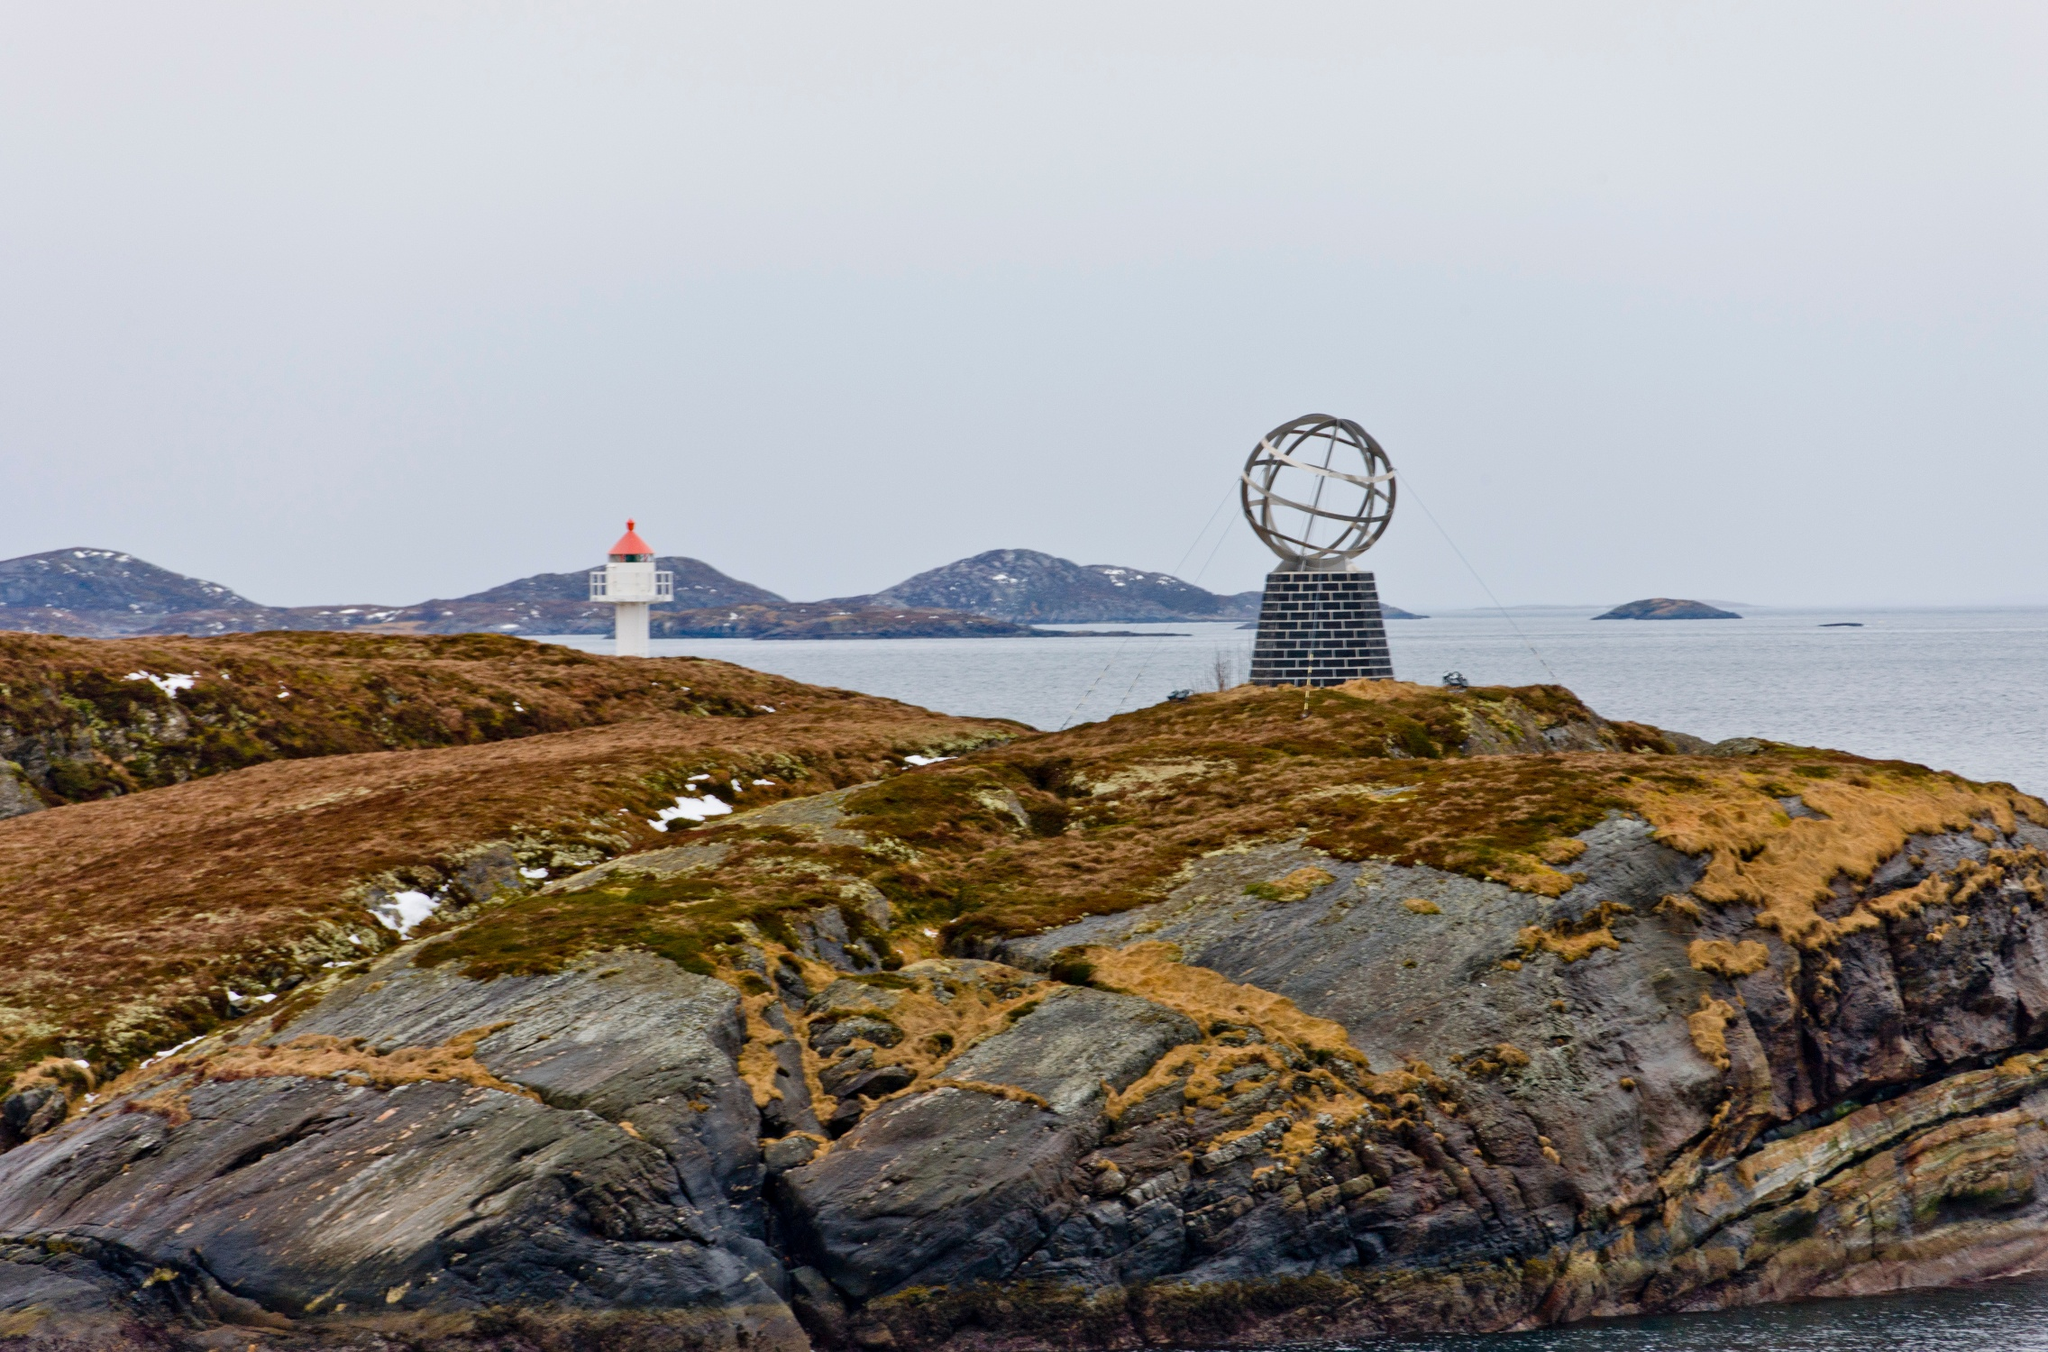What is this photo about? This photo captures the iconic North Cape in Northern Norway, known for its breathtaking seascapes and unique geographical landmarks. Center stage in the image is the large metal globe sculpture perched on a rugged stone pedestal, symbolizing its status as one of the northernmost accessible points in Europe. This sculpture, gleaming against the overcast sky, serves as an enticing focal point for visitors from around the world. The composition skillfully balances this man-made marvel with the expansive natural beauty of the North, including a quaint white and red lighthouse seen in the distance, stationed on an islet. This beacon of light represents isolation yet connectivity, guiding seafarers through the treacherous Arctic waters. The overall mood of the photo, with its muted colors and soft lighting, encapsulates the serene yet formidable essence of the Arctic landscape. 